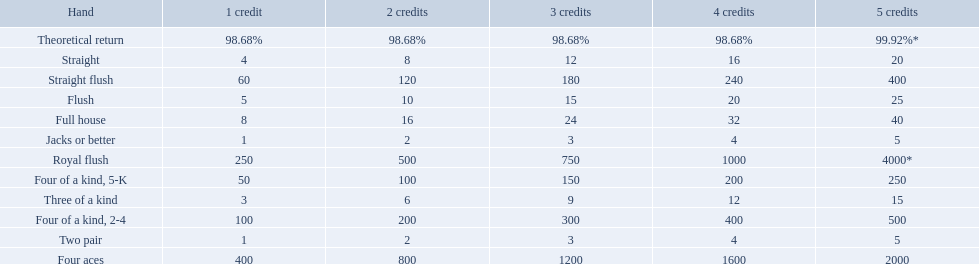What are the hands? Royal flush, Straight flush, Four aces, Four of a kind, 2-4, Four of a kind, 5-K, Full house, Flush, Straight, Three of a kind, Two pair, Jacks or better. Which hand is on the top? Royal flush. Which hand is the third best hand in the card game super aces? Four aces. Which hand is the second best hand? Straight flush. Which hand had is the best hand? Royal flush. 